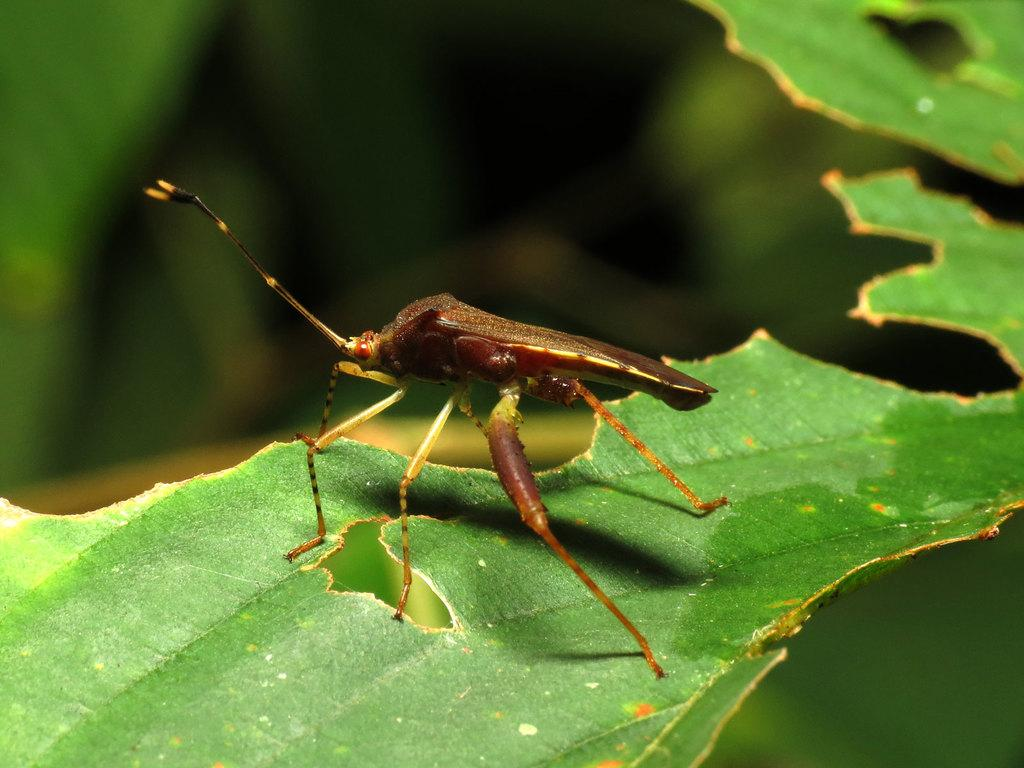What is present on the leaf in the image? There is an insect on the leaf in the image. What is the primary subject of the image? The primary subject of the image is an insect. How would you describe the background of the image? The background of the image is blurred. What type of furniture can be seen in the image? There is no furniture present in the image; it features an insect on a leaf with a blurred background. 